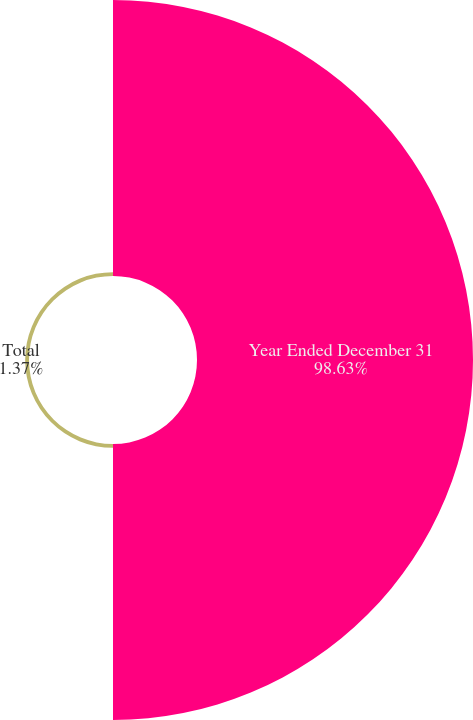Convert chart to OTSL. <chart><loc_0><loc_0><loc_500><loc_500><pie_chart><fcel>Year Ended December 31<fcel>Total<nl><fcel>98.63%<fcel>1.37%<nl></chart> 